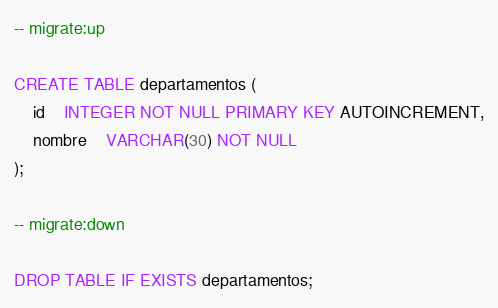Convert code to text. <code><loc_0><loc_0><loc_500><loc_500><_SQL_>-- migrate:up

CREATE TABLE departamentos (
	id	INTEGER NOT NULL PRIMARY KEY AUTOINCREMENT,
	nombre	VARCHAR(30) NOT NULL
);

-- migrate:down

DROP TABLE IF EXISTS departamentos;
</code> 